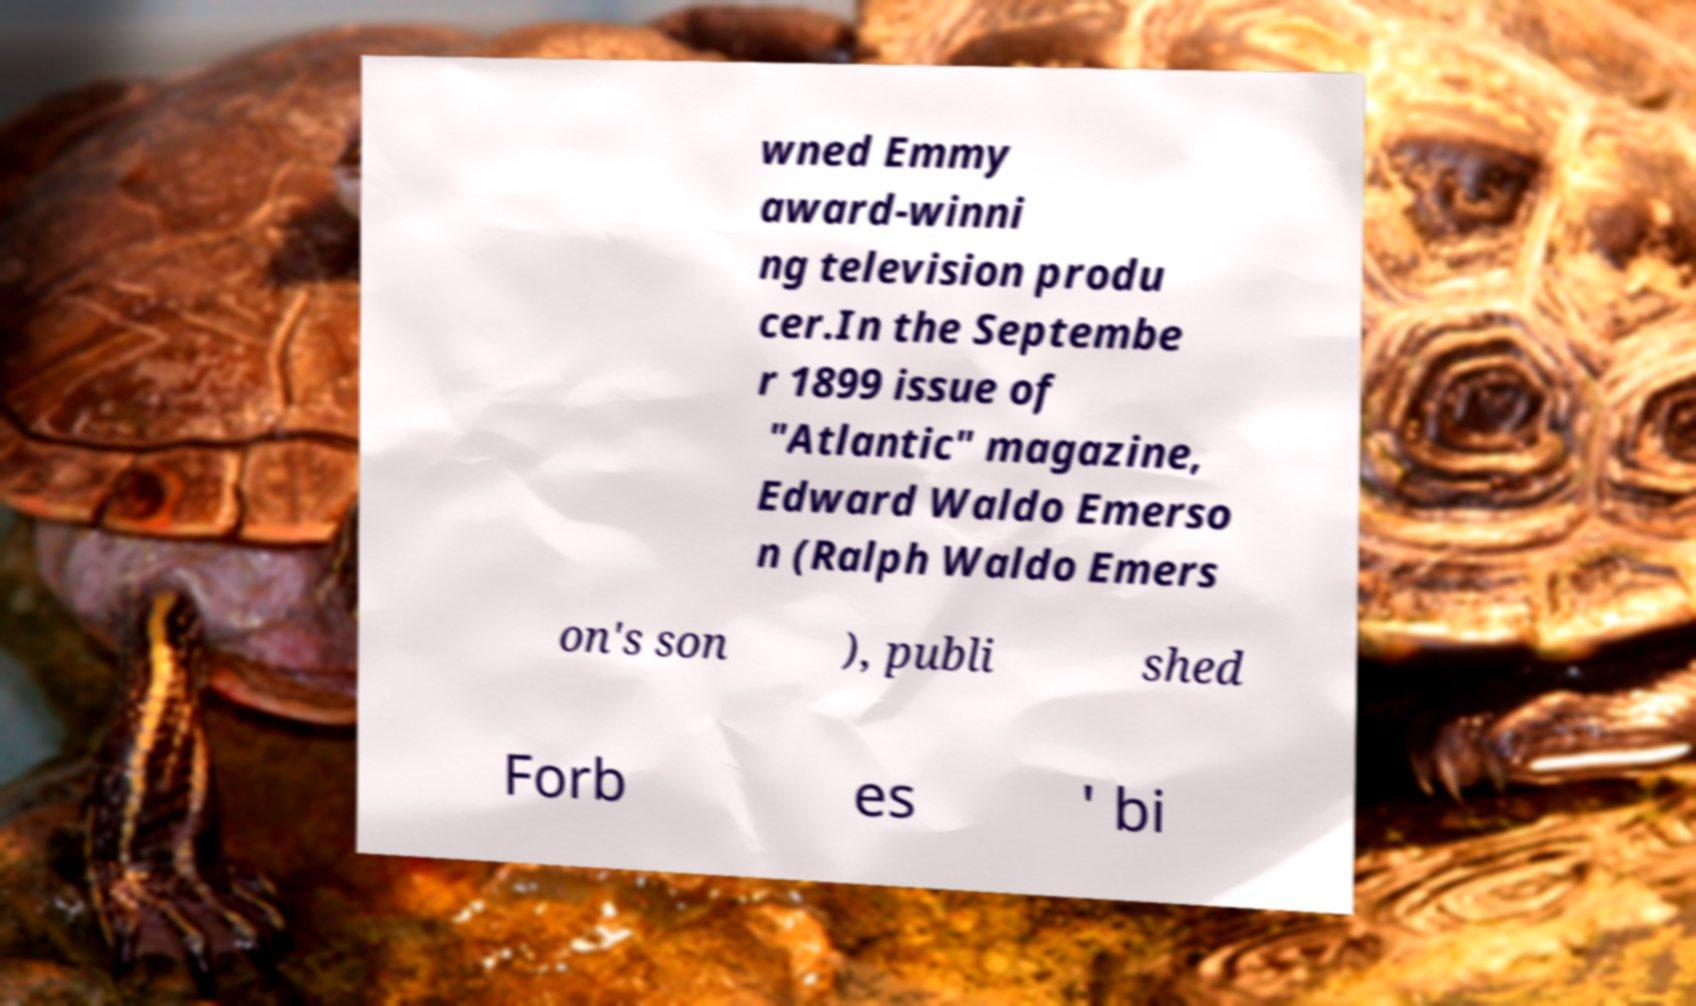Please identify and transcribe the text found in this image. wned Emmy award-winni ng television produ cer.In the Septembe r 1899 issue of "Atlantic" magazine, Edward Waldo Emerso n (Ralph Waldo Emers on's son ), publi shed Forb es ' bi 